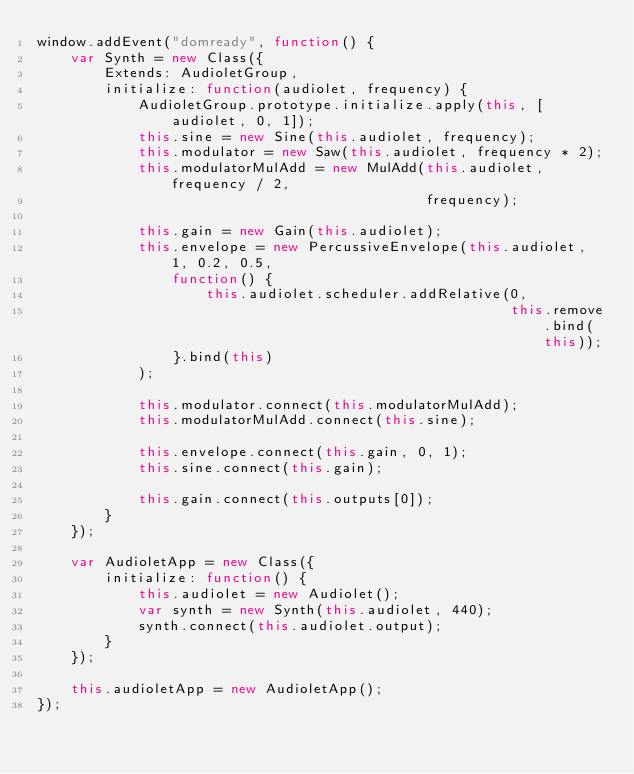Convert code to text. <code><loc_0><loc_0><loc_500><loc_500><_JavaScript_>window.addEvent("domready", function() {
    var Synth = new Class({
        Extends: AudioletGroup,
        initialize: function(audiolet, frequency) {
            AudioletGroup.prototype.initialize.apply(this, [audiolet, 0, 1]);
            this.sine = new Sine(this.audiolet, frequency);
            this.modulator = new Saw(this.audiolet, frequency * 2);
            this.modulatorMulAdd = new MulAdd(this.audiolet, frequency / 2,
                                              frequency);

            this.gain = new Gain(this.audiolet);
            this.envelope = new PercussiveEnvelope(this.audiolet, 1, 0.2, 0.5,
                function() {
                    this.audiolet.scheduler.addRelative(0,
                                                        this.remove.bind(this));
                }.bind(this)
            );

            this.modulator.connect(this.modulatorMulAdd);
            this.modulatorMulAdd.connect(this.sine);

            this.envelope.connect(this.gain, 0, 1);
            this.sine.connect(this.gain);

            this.gain.connect(this.outputs[0]);
        }
    });

    var AudioletApp = new Class({
        initialize: function() {
            this.audiolet = new Audiolet();
            var synth = new Synth(this.audiolet, 440);
            synth.connect(this.audiolet.output);
        }
    });

    this.audioletApp = new AudioletApp();
});


</code> 